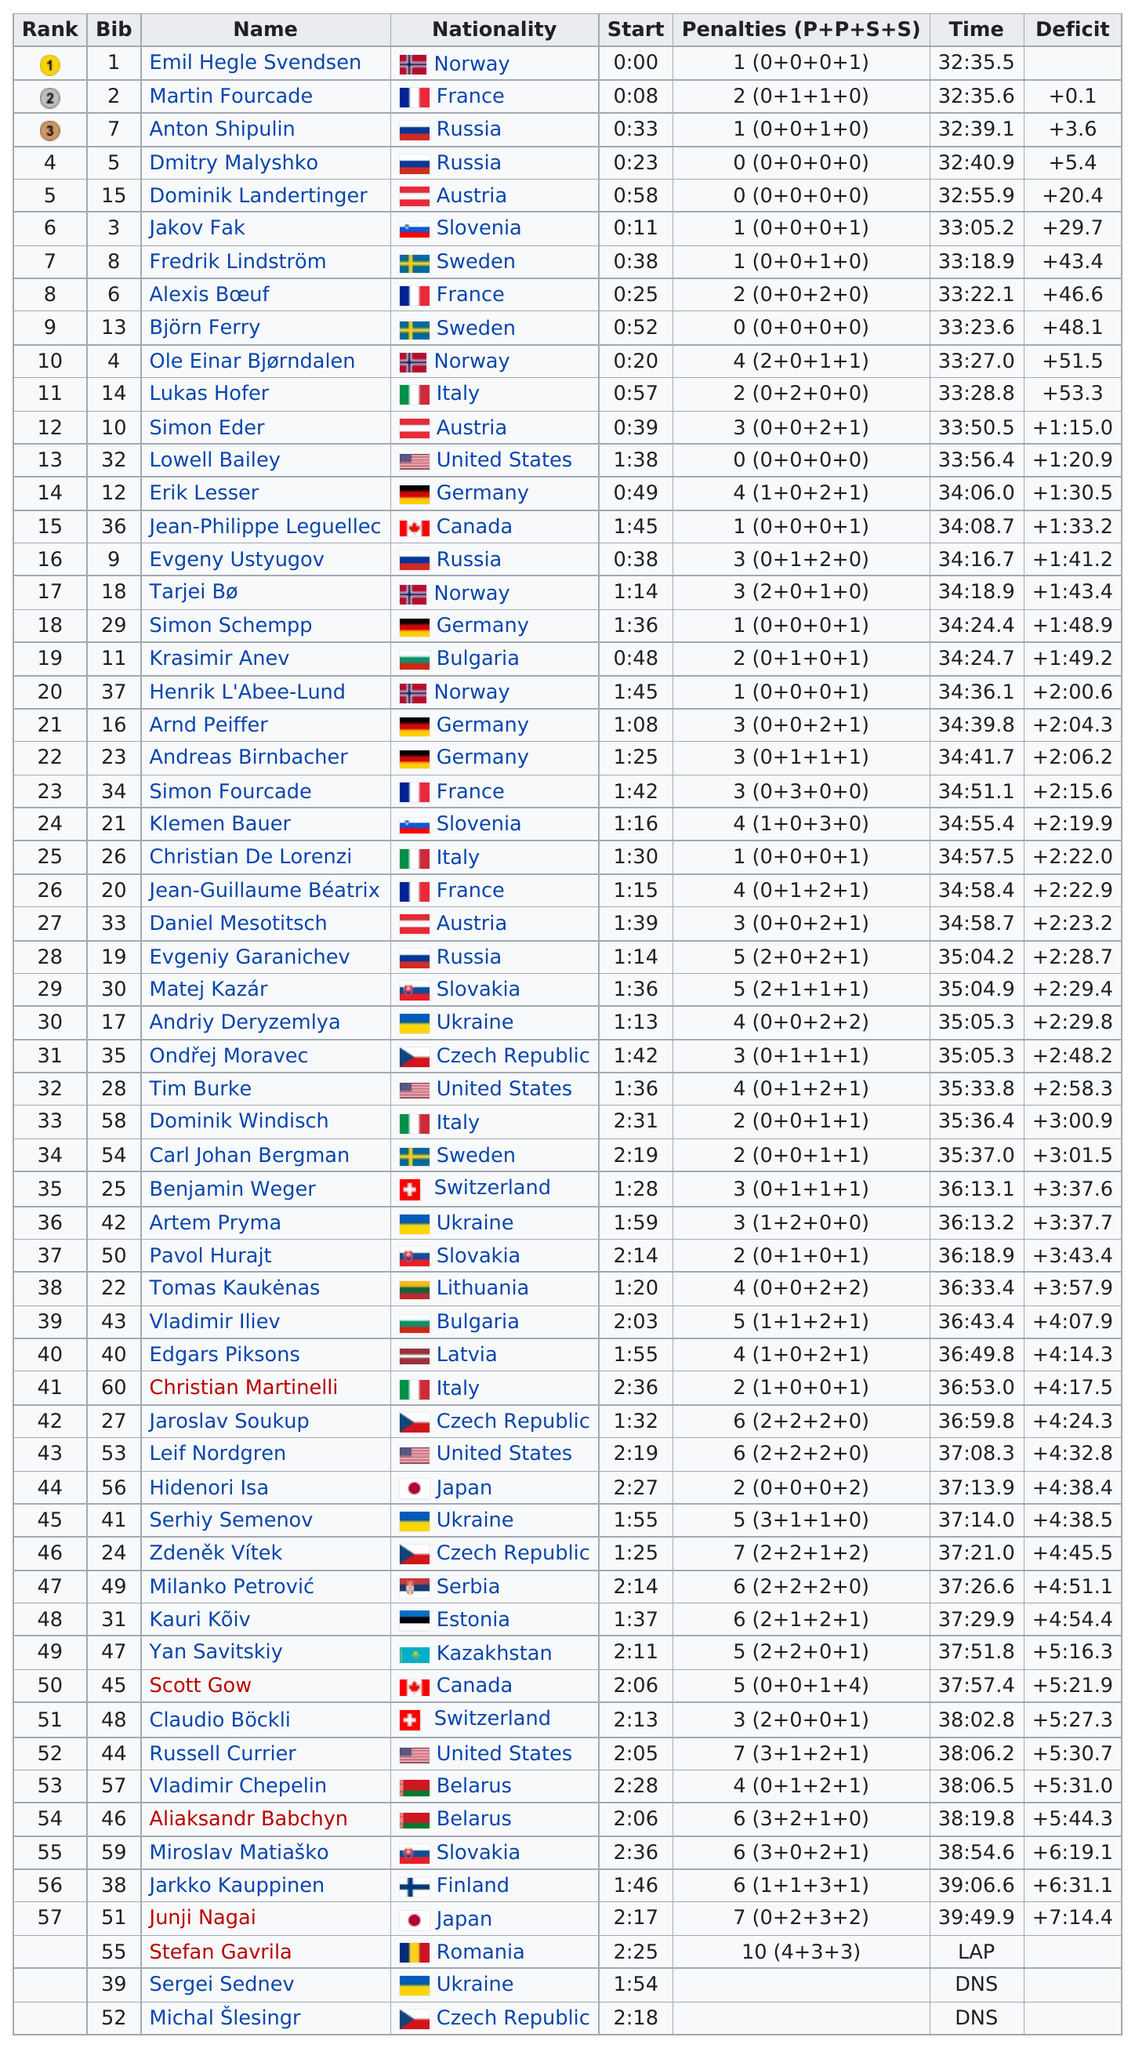Indicate a few pertinent items in this graphic. There were 4 Russian participants in total. Erik Lesser completed the task in 34 minutes and 6 seconds. Stefan Gavrila received the most penalties. According to Bjorn Ferry, Simon Elder, and Erik Lesser, Erik Lesser had the most penalties. Out of the runners who finished the race, how many took at least 35 minutes to complete the race? 